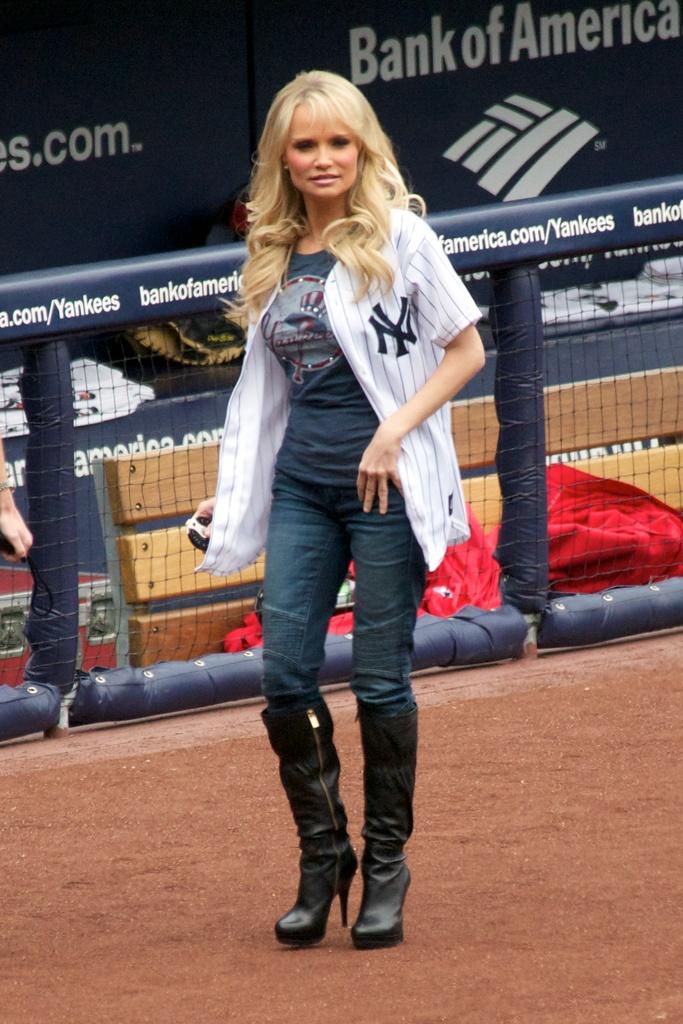What bank is sponsoring this team?
Your answer should be very brief. Bank of america. What is the team being supported?
Your response must be concise. Yankees. 